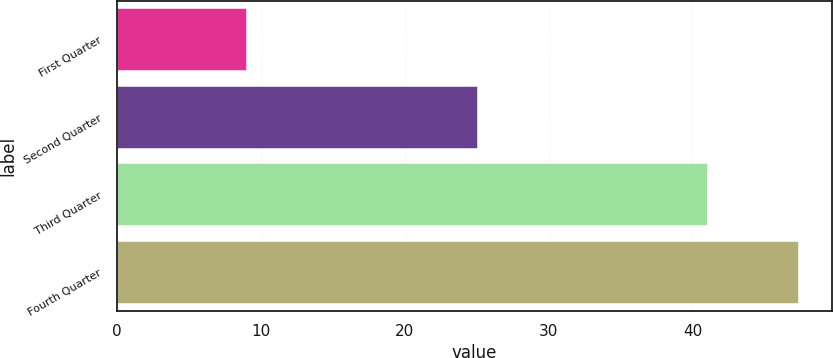Convert chart to OTSL. <chart><loc_0><loc_0><loc_500><loc_500><bar_chart><fcel>First Quarter<fcel>Second Quarter<fcel>Third Quarter<fcel>Fourth Quarter<nl><fcel>8.97<fcel>25.03<fcel>41.03<fcel>47.32<nl></chart> 